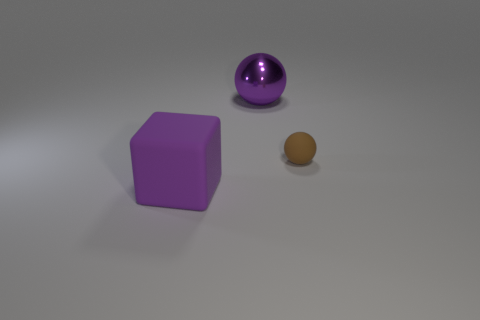Is there anything else that is the same size as the brown matte thing?
Offer a very short reply. No. How many blocks are either brown rubber objects or tiny purple metallic things?
Keep it short and to the point. 0. What is the size of the brown ball that is made of the same material as the block?
Make the answer very short. Small. How many metal spheres have the same color as the cube?
Provide a succinct answer. 1. There is a matte sphere; are there any large purple rubber cubes to the left of it?
Your response must be concise. Yes. Is the shape of the large metal thing the same as the rubber object to the right of the large purple rubber block?
Provide a short and direct response. Yes. What number of objects are either large purple things left of the large purple shiny sphere or green cubes?
Make the answer very short. 1. Is there any other thing that has the same material as the purple sphere?
Keep it short and to the point. No. What number of objects are both left of the tiny thing and in front of the large sphere?
Offer a very short reply. 1. What number of objects are either large purple things in front of the small brown sphere or purple things that are in front of the metal ball?
Your response must be concise. 1. 